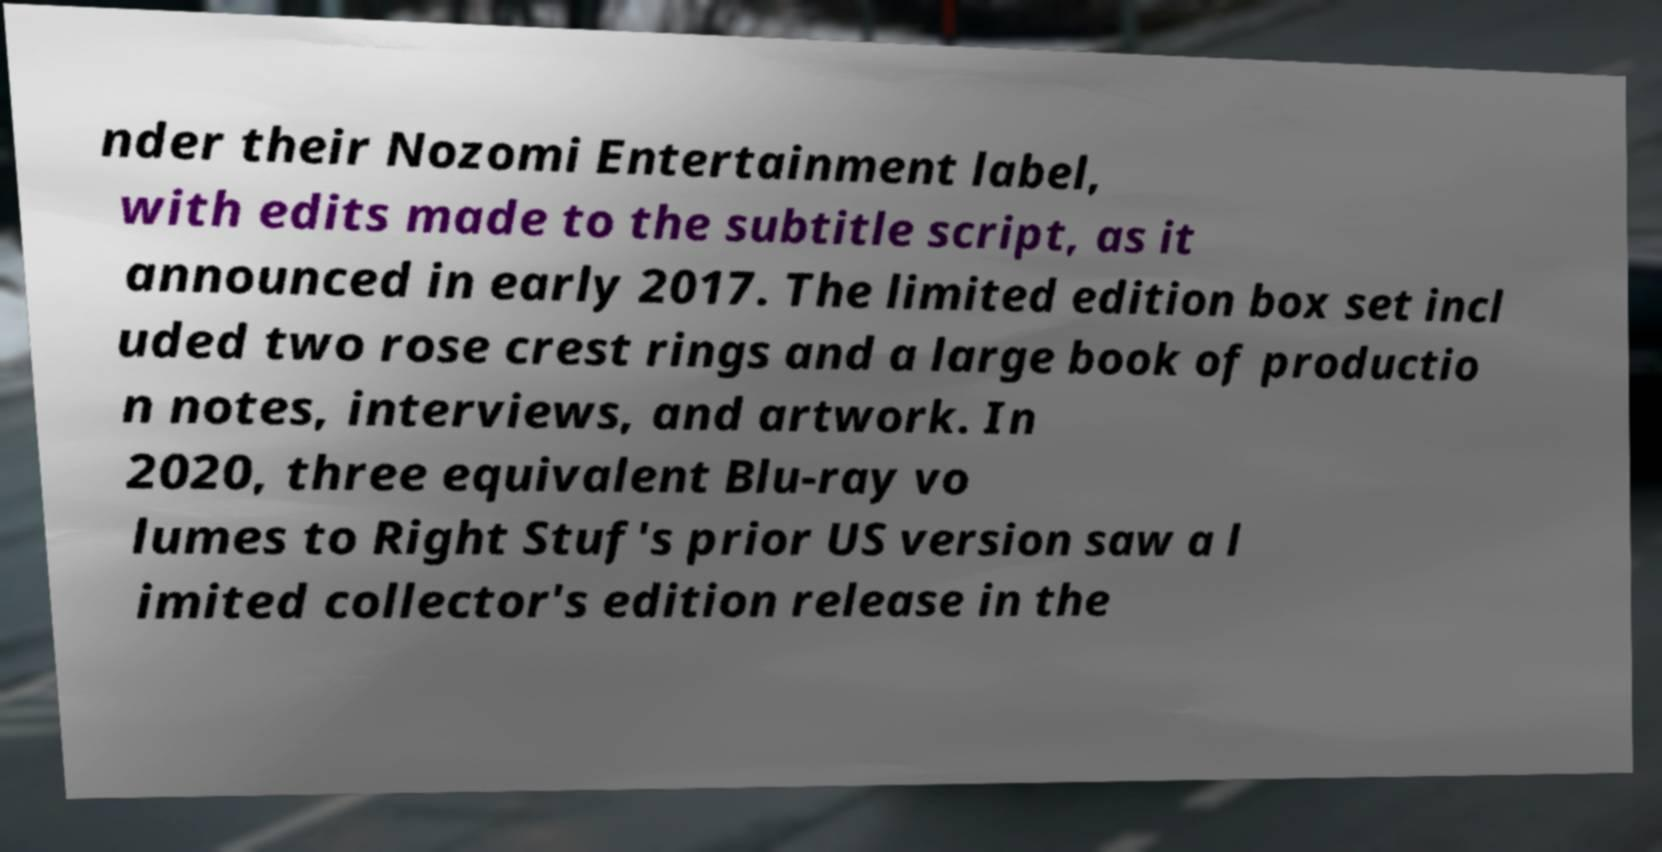Can you read and provide the text displayed in the image?This photo seems to have some interesting text. Can you extract and type it out for me? nder their Nozomi Entertainment label, with edits made to the subtitle script, as it announced in early 2017. The limited edition box set incl uded two rose crest rings and a large book of productio n notes, interviews, and artwork. In 2020, three equivalent Blu-ray vo lumes to Right Stuf's prior US version saw a l imited collector's edition release in the 